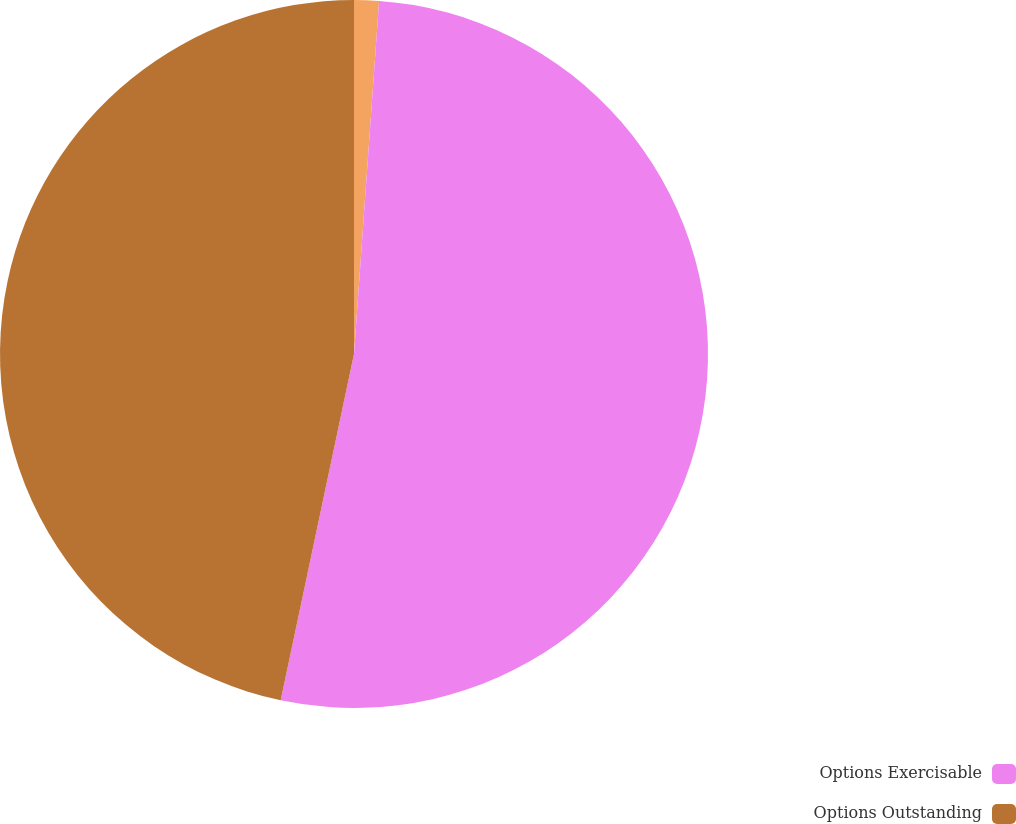<chart> <loc_0><loc_0><loc_500><loc_500><pie_chart><ecel><fcel>Options Exercisable<fcel>Options Outstanding<nl><fcel>1.13%<fcel>52.19%<fcel>46.68%<nl></chart> 